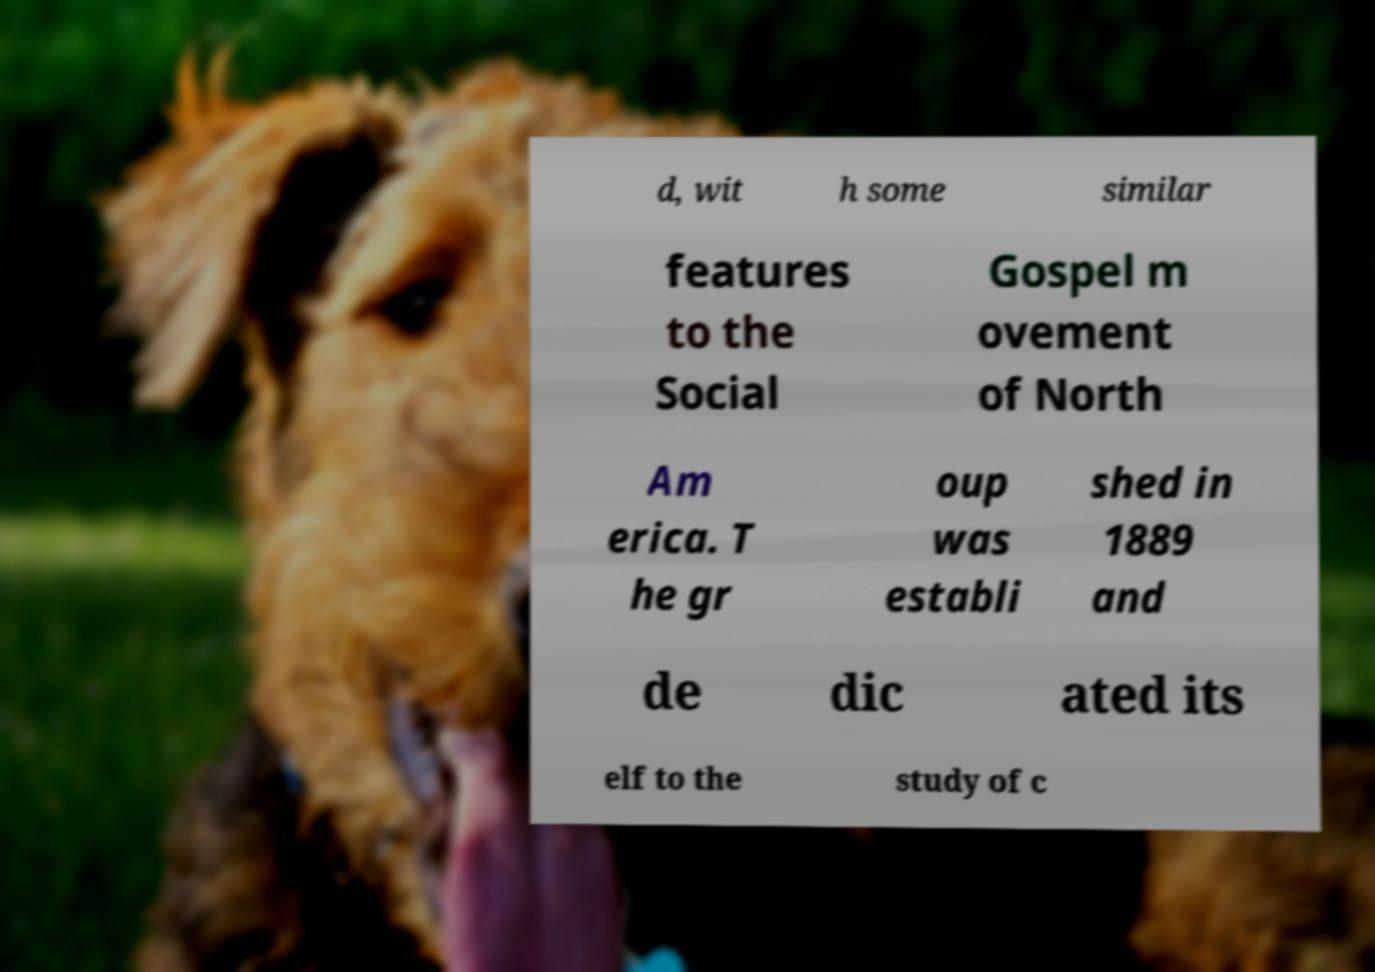For documentation purposes, I need the text within this image transcribed. Could you provide that? d, wit h some similar features to the Social Gospel m ovement of North Am erica. T he gr oup was establi shed in 1889 and de dic ated its elf to the study of c 